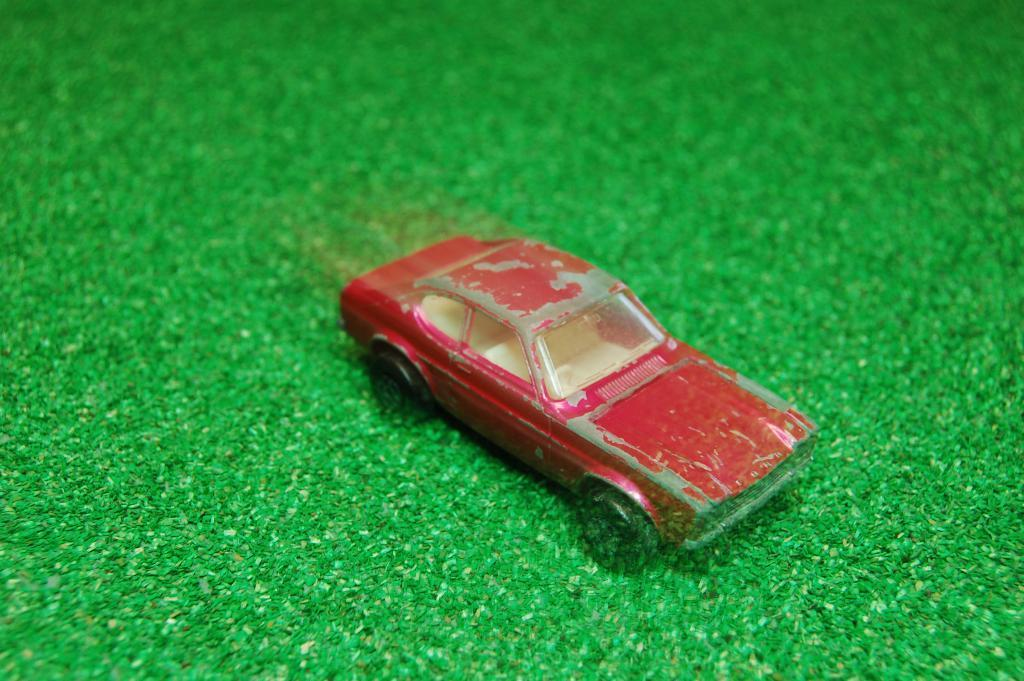What type of toy is in the picture? There is a toy car in the picture. What type of surface is at the bottom of the picture? There is artificial grass at the bottom of the picture. How does the baby use the hook in the picture? There is no baby or hook present in the picture; it only features a toy car and artificial grass. 